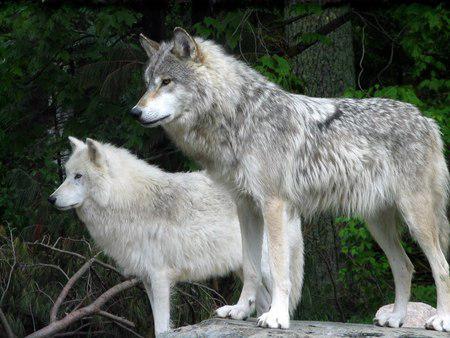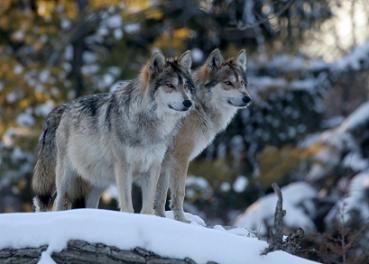The first image is the image on the left, the second image is the image on the right. For the images displayed, is the sentence "An image shows two non-standing wolves with heads nuzzling close together." factually correct? Answer yes or no. No. The first image is the image on the left, the second image is the image on the right. Given the left and right images, does the statement "a pair of wolves are cuddling with faces close" hold true? Answer yes or no. No. 